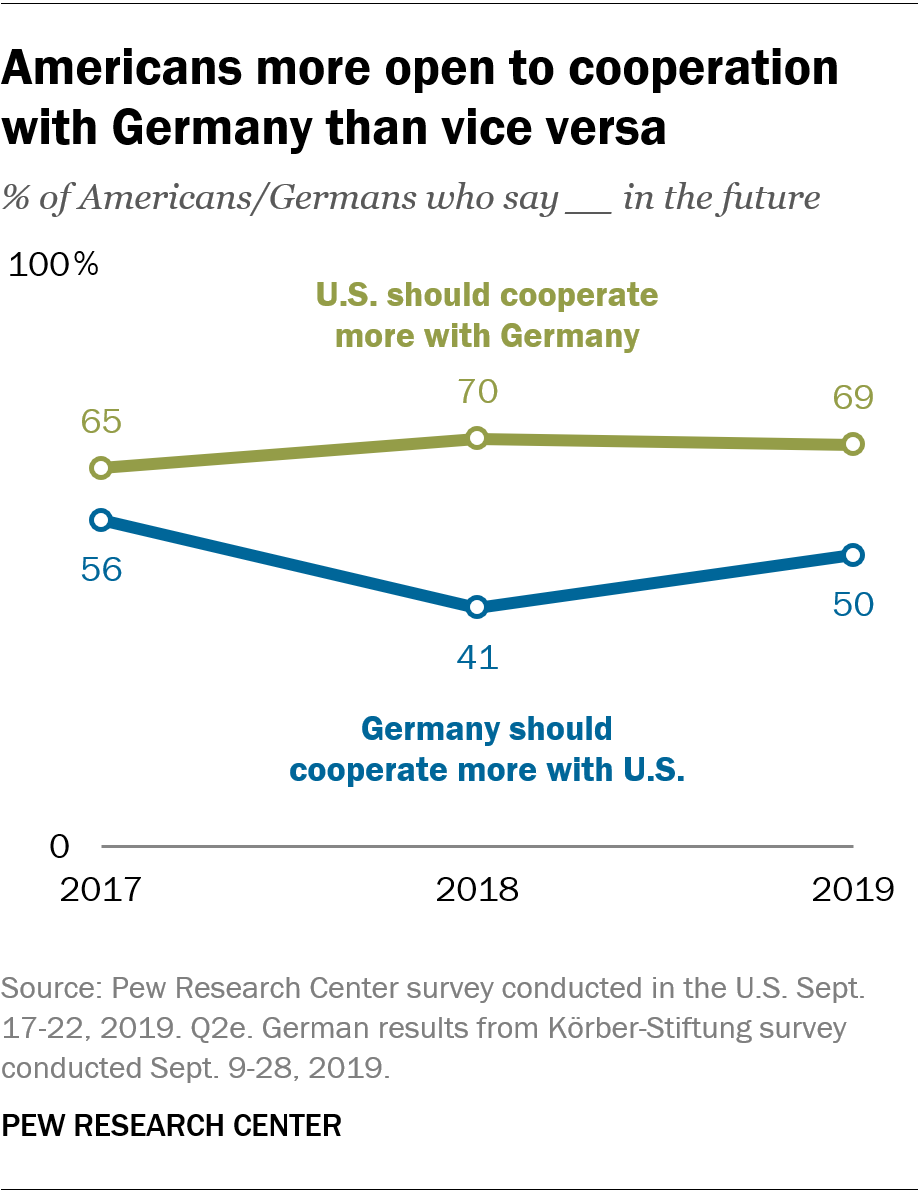Indicate a few pertinent items in this graphic. In 2017, the difference between the green and blue graph was at its lowest. According to a survey conducted in 2019, 69% of Americans and Germans believe that the United States should cooperate more with Germany. 